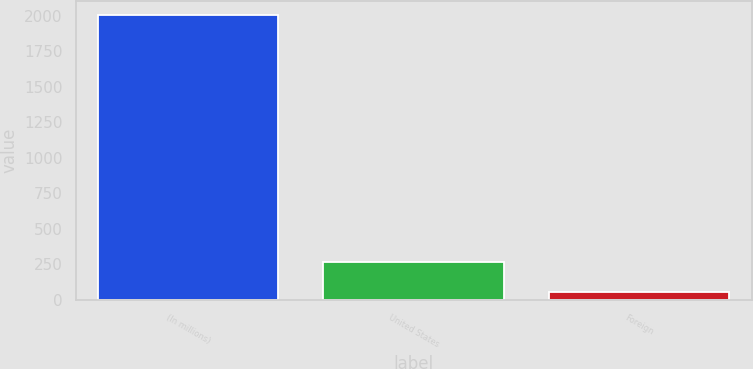Convert chart to OTSL. <chart><loc_0><loc_0><loc_500><loc_500><bar_chart><fcel>(In millions)<fcel>United States<fcel>Foreign<nl><fcel>2002<fcel>264.5<fcel>50.4<nl></chart> 